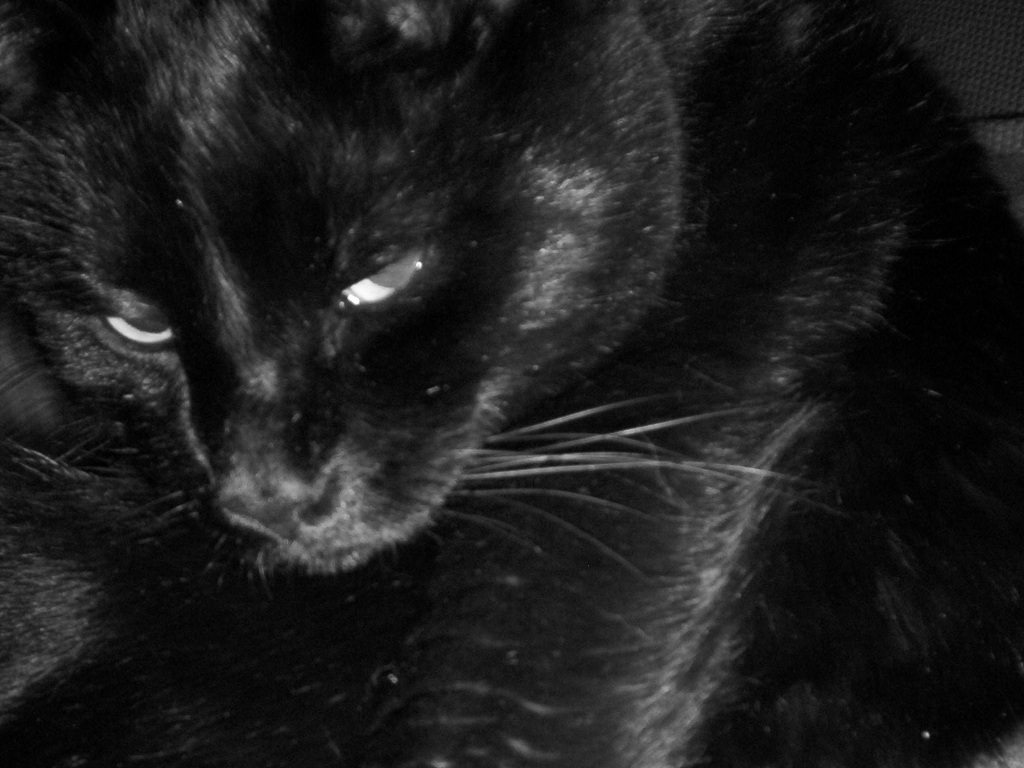What kind of mood does this image evoke? The image evokes a mysterious and introspective mood. The black cat, often associated with superstition and mystique, coupled with the low-key lighting, gives the image an intriguing and somewhat enigmatic quality. 